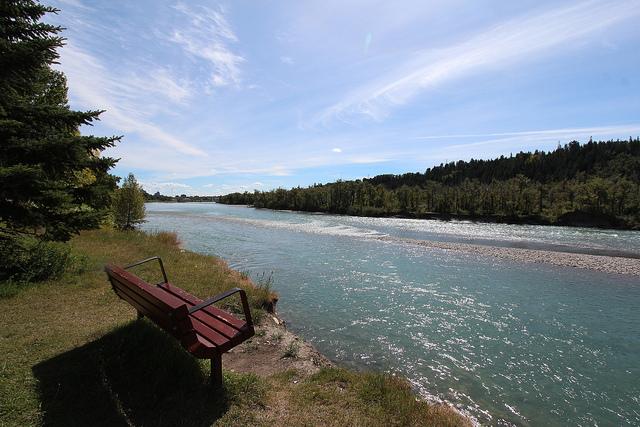How would we describe the condition of the benches?
Keep it brief. Good. How many people are at the bench?
Keep it brief. 0. What color is the water?
Keep it brief. Blue. Is the object still usable for it's intended use?
Quick response, please. Yes. What side of the water is the bench facing?
Short answer required. Left. 